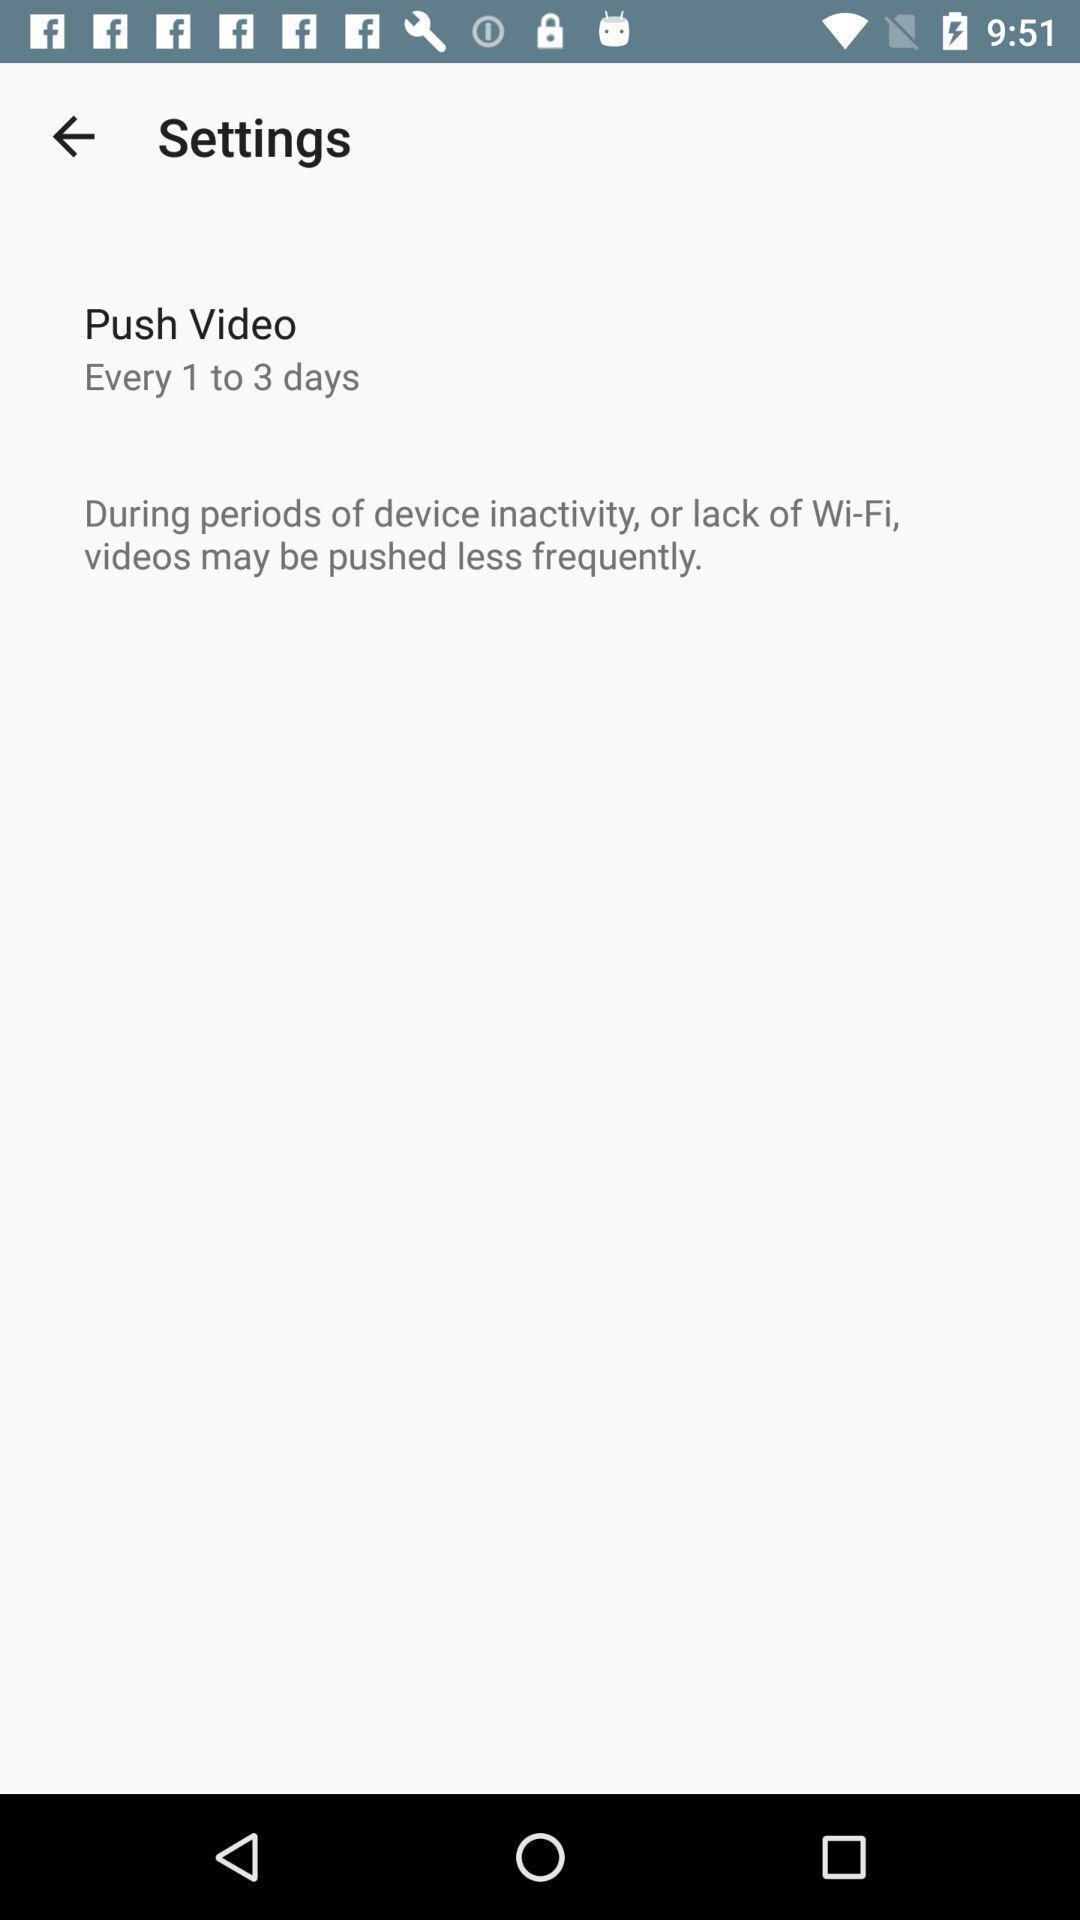Summarize the main components in this picture. Settings page. 